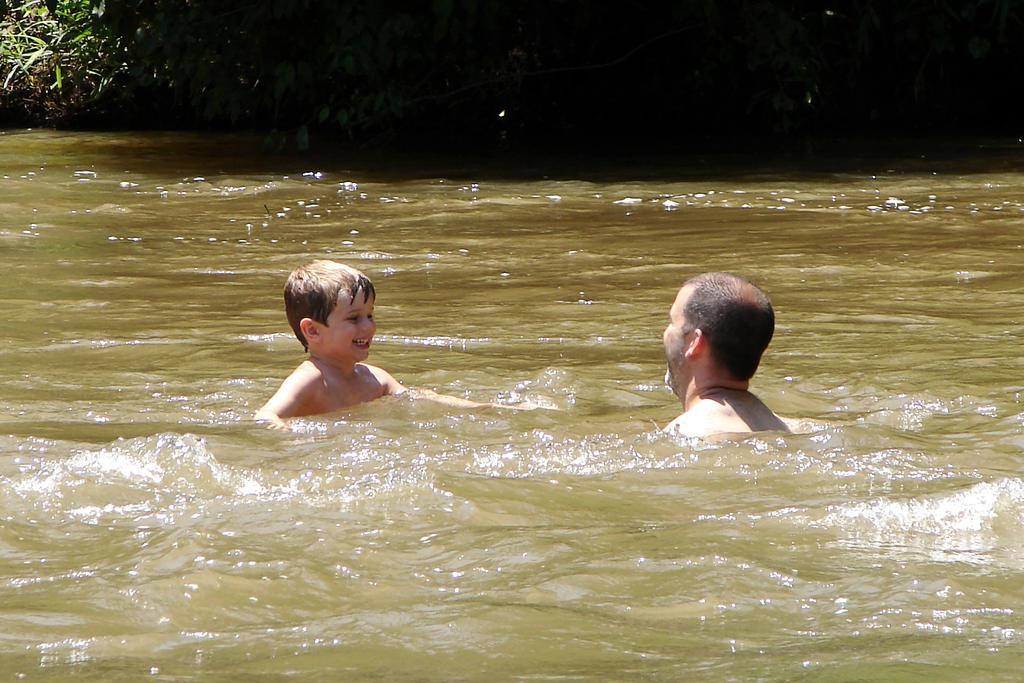How would you summarize this image in a sentence or two? In this image, I can see two persons in the water. At the top of the image, I can see the plants. 